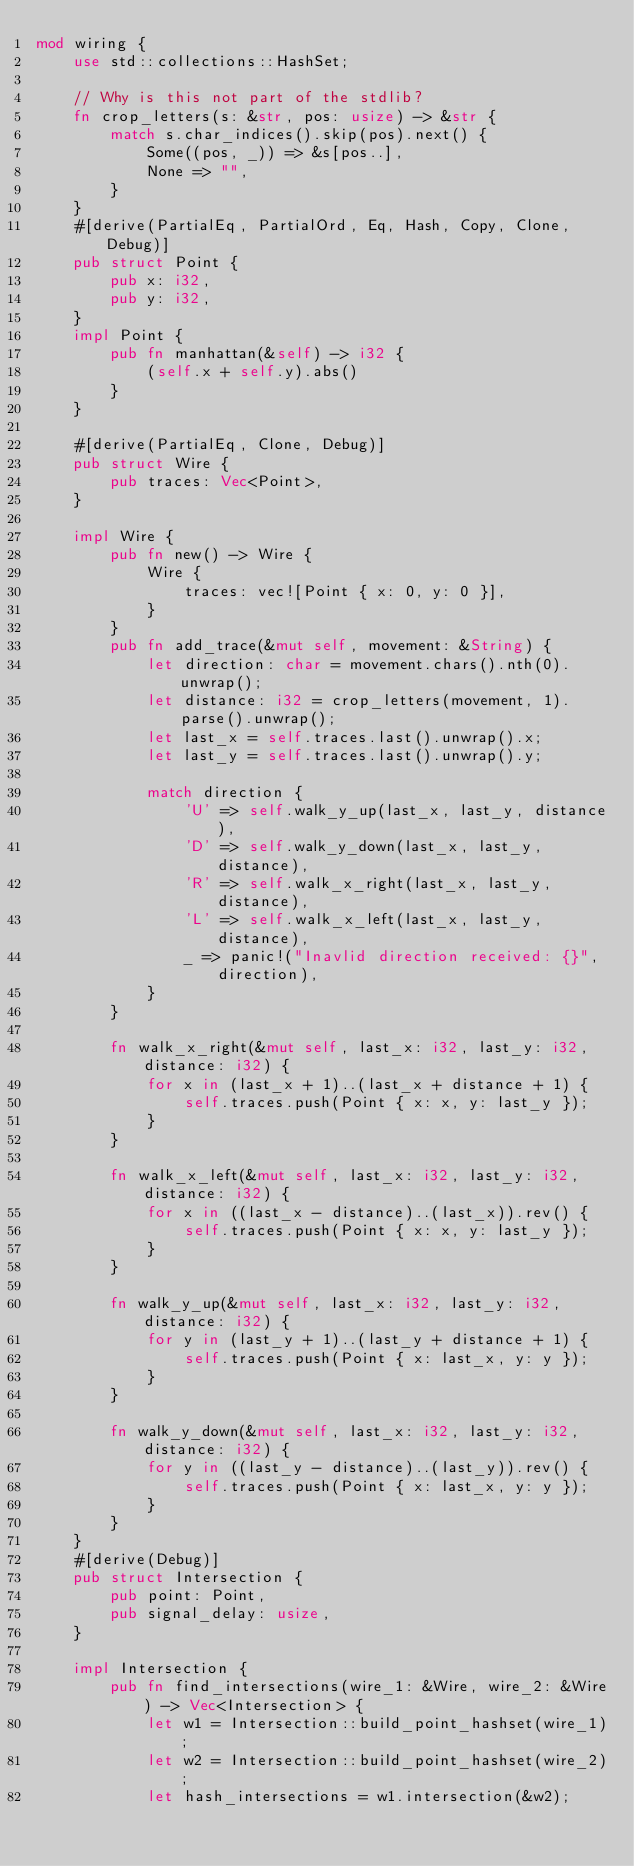<code> <loc_0><loc_0><loc_500><loc_500><_Rust_>mod wiring {
    use std::collections::HashSet;

    // Why is this not part of the stdlib?
    fn crop_letters(s: &str, pos: usize) -> &str {
        match s.char_indices().skip(pos).next() {
            Some((pos, _)) => &s[pos..],
            None => "",
        }
    }
    #[derive(PartialEq, PartialOrd, Eq, Hash, Copy, Clone, Debug)]
    pub struct Point {
        pub x: i32,
        pub y: i32,
    }
    impl Point {
        pub fn manhattan(&self) -> i32 {
            (self.x + self.y).abs()
        }
    }

    #[derive(PartialEq, Clone, Debug)]
    pub struct Wire {
        pub traces: Vec<Point>,
    }

    impl Wire {
        pub fn new() -> Wire {
            Wire {
                traces: vec![Point { x: 0, y: 0 }],
            }
        }
        pub fn add_trace(&mut self, movement: &String) {
            let direction: char = movement.chars().nth(0).unwrap();
            let distance: i32 = crop_letters(movement, 1).parse().unwrap();
            let last_x = self.traces.last().unwrap().x;
            let last_y = self.traces.last().unwrap().y;

            match direction {
                'U' => self.walk_y_up(last_x, last_y, distance),
                'D' => self.walk_y_down(last_x, last_y, distance),
                'R' => self.walk_x_right(last_x, last_y, distance),
                'L' => self.walk_x_left(last_x, last_y, distance),
                _ => panic!("Inavlid direction received: {}", direction),
            }
        }

        fn walk_x_right(&mut self, last_x: i32, last_y: i32, distance: i32) {
            for x in (last_x + 1)..(last_x + distance + 1) {
                self.traces.push(Point { x: x, y: last_y });
            }
        }

        fn walk_x_left(&mut self, last_x: i32, last_y: i32, distance: i32) {
            for x in ((last_x - distance)..(last_x)).rev() {
                self.traces.push(Point { x: x, y: last_y });
            }
        }

        fn walk_y_up(&mut self, last_x: i32, last_y: i32, distance: i32) {
            for y in (last_y + 1)..(last_y + distance + 1) {
                self.traces.push(Point { x: last_x, y: y });
            }
        }

        fn walk_y_down(&mut self, last_x: i32, last_y: i32, distance: i32) {
            for y in ((last_y - distance)..(last_y)).rev() {
                self.traces.push(Point { x: last_x, y: y });
            }
        }
    }
    #[derive(Debug)]
    pub struct Intersection {
        pub point: Point,
        pub signal_delay: usize,
    }

    impl Intersection {
        pub fn find_intersections(wire_1: &Wire, wire_2: &Wire) -> Vec<Intersection> {
            let w1 = Intersection::build_point_hashset(wire_1);
            let w2 = Intersection::build_point_hashset(wire_2);
            let hash_intersections = w1.intersection(&w2);</code> 